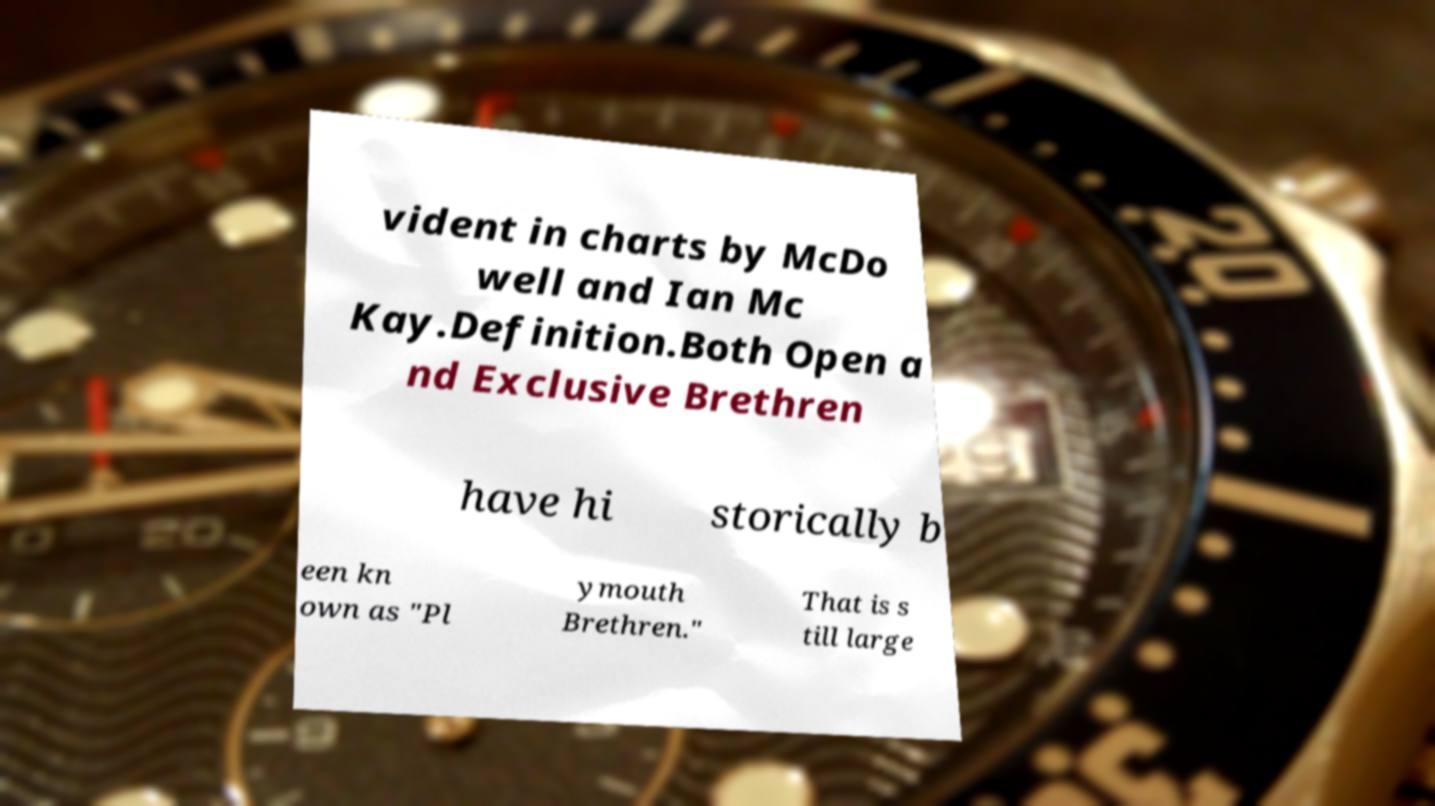Could you assist in decoding the text presented in this image and type it out clearly? vident in charts by McDo well and Ian Mc Kay.Definition.Both Open a nd Exclusive Brethren have hi storically b een kn own as "Pl ymouth Brethren." That is s till large 